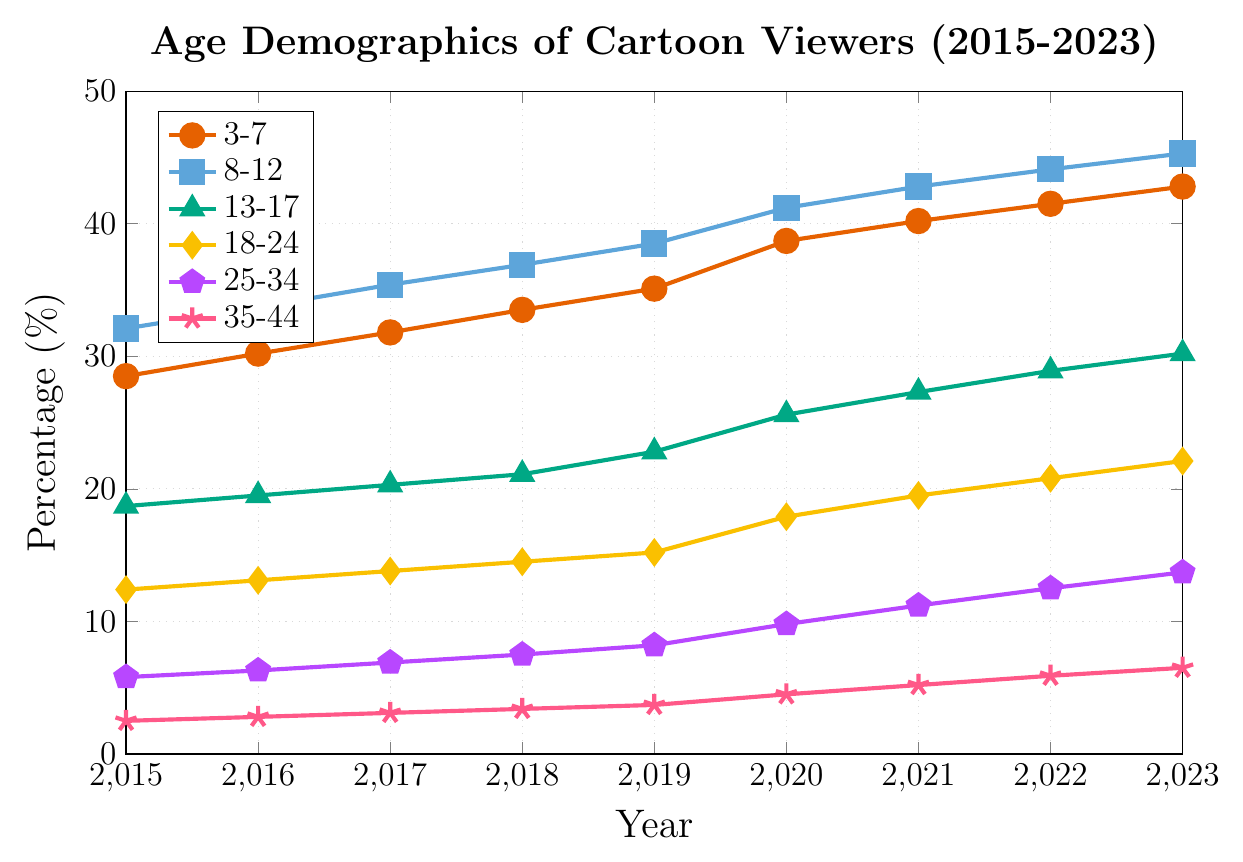Which age group had the highest percentage of cartoon viewers in 2023? To find the highest percentage in 2023, look at the endpoint for each line and identify the highest value on the y-axis. The age group 8-12 has the highest value at 45.3%.
Answer: 8-12 How did the percentage of viewers aged 35-44 change from 2015 to 2023? Look at the starting percentage in 2015 (2.5%) and the ending percentage in 2023 (6.5%). Subtract the starting percentage from the ending percentage: 6.5% - 2.5% = 4%. The percentage increased by 4%.
Answer: increased by 4% Which two age groups had a similar trend in growth patterns over the years? Examine the slopes of the lines representing each age group. Both the 3-7 and 8-12 age groups show a consistent upward trend without drastic changes, indicating a similar growth pattern.
Answer: 3-7 and 8-12 What is the combined percentage of viewers aged 25-34 and 35-44 in 2020? Look at the percentages for these age groups in 2020. For ages 25-34, it's 9.8%, and for ages 35-44, it's 4.5%. Add these percentages: 9.8% + 4.5% = 14.3%.
Answer: 14.3% Which age group saw the largest increase in percentage points from 2019 to 2020? Calculate the increase for each group by subtracting the 2019 percentage from the 2020 percentage. The age group 3-7 increased from 35.1% to 38.7%, a change of 3.6%. This is the largest increase among the age groups.
Answer: 3-7 Between 2018 and 2023, which age group had the smallest increase in percentages? Calculate the absolute change for each age group between these years. The age group 35-44 increased from 3.4% to 6.5%, which is an increase of 3.1%, the smallest among the age groups.
Answer: 35-44 How many age groups had a larger percentage of viewers than the 18-24 group in 2021? The 18-24 group had a percentage of 19.5% in 2021. The 3-7, 8-12, and 13-17 age groups all had higher percentages. This means three age groups had a larger percentage of viewers.
Answer: 3 